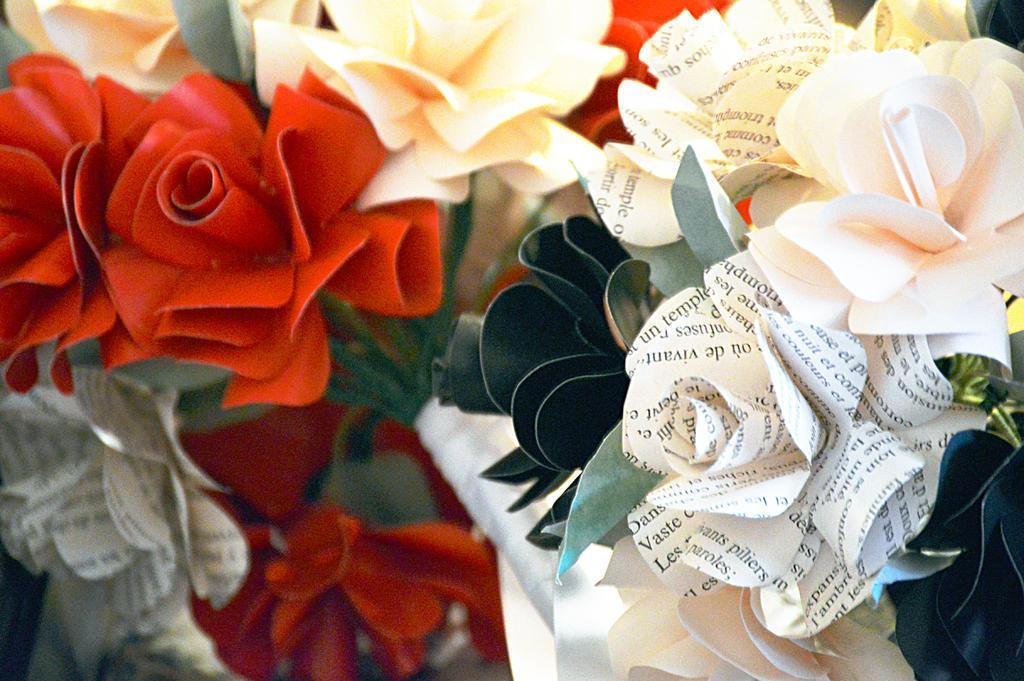Describe this image in one or two sentences. In this image I can see many paper flowers which are colorful. 